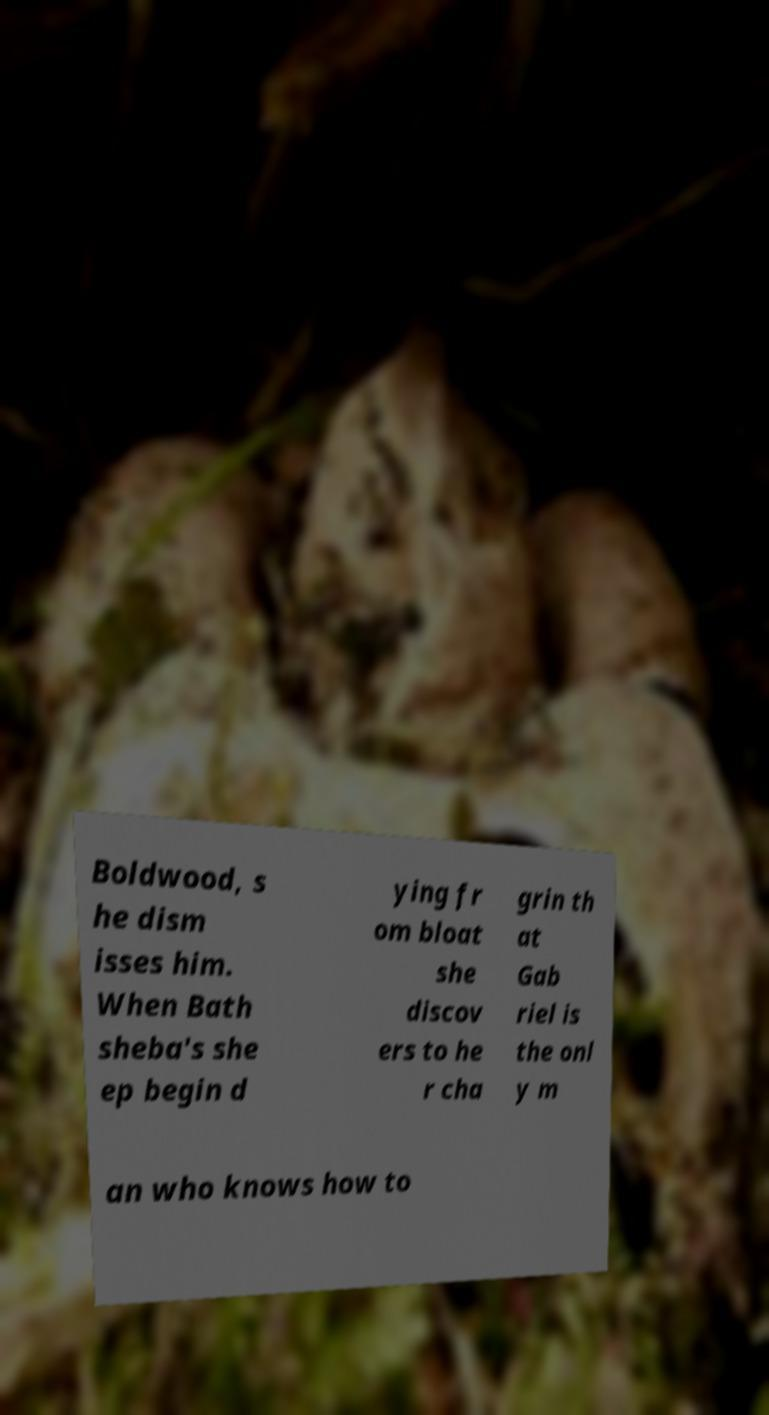What messages or text are displayed in this image? I need them in a readable, typed format. Boldwood, s he dism isses him. When Bath sheba's she ep begin d ying fr om bloat she discov ers to he r cha grin th at Gab riel is the onl y m an who knows how to 